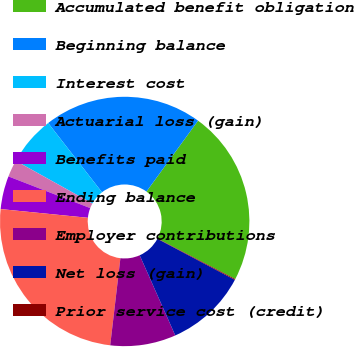Convert chart. <chart><loc_0><loc_0><loc_500><loc_500><pie_chart><fcel>Accumulated benefit obligation<fcel>Beginning balance<fcel>Interest cost<fcel>Actuarial loss (gain)<fcel>Benefits paid<fcel>Ending balance<fcel>Employer contributions<fcel>Net loss (gain)<fcel>Prior service cost (credit)<nl><fcel>22.63%<fcel>20.53%<fcel>6.4%<fcel>2.2%<fcel>4.3%<fcel>24.73%<fcel>8.5%<fcel>10.6%<fcel>0.11%<nl></chart> 